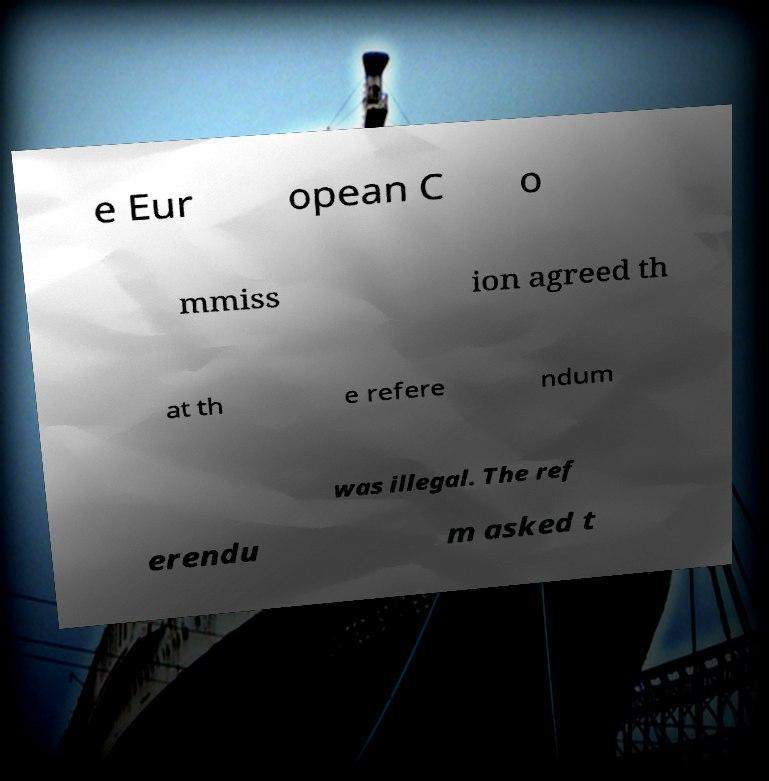Can you accurately transcribe the text from the provided image for me? e Eur opean C o mmiss ion agreed th at th e refere ndum was illegal. The ref erendu m asked t 